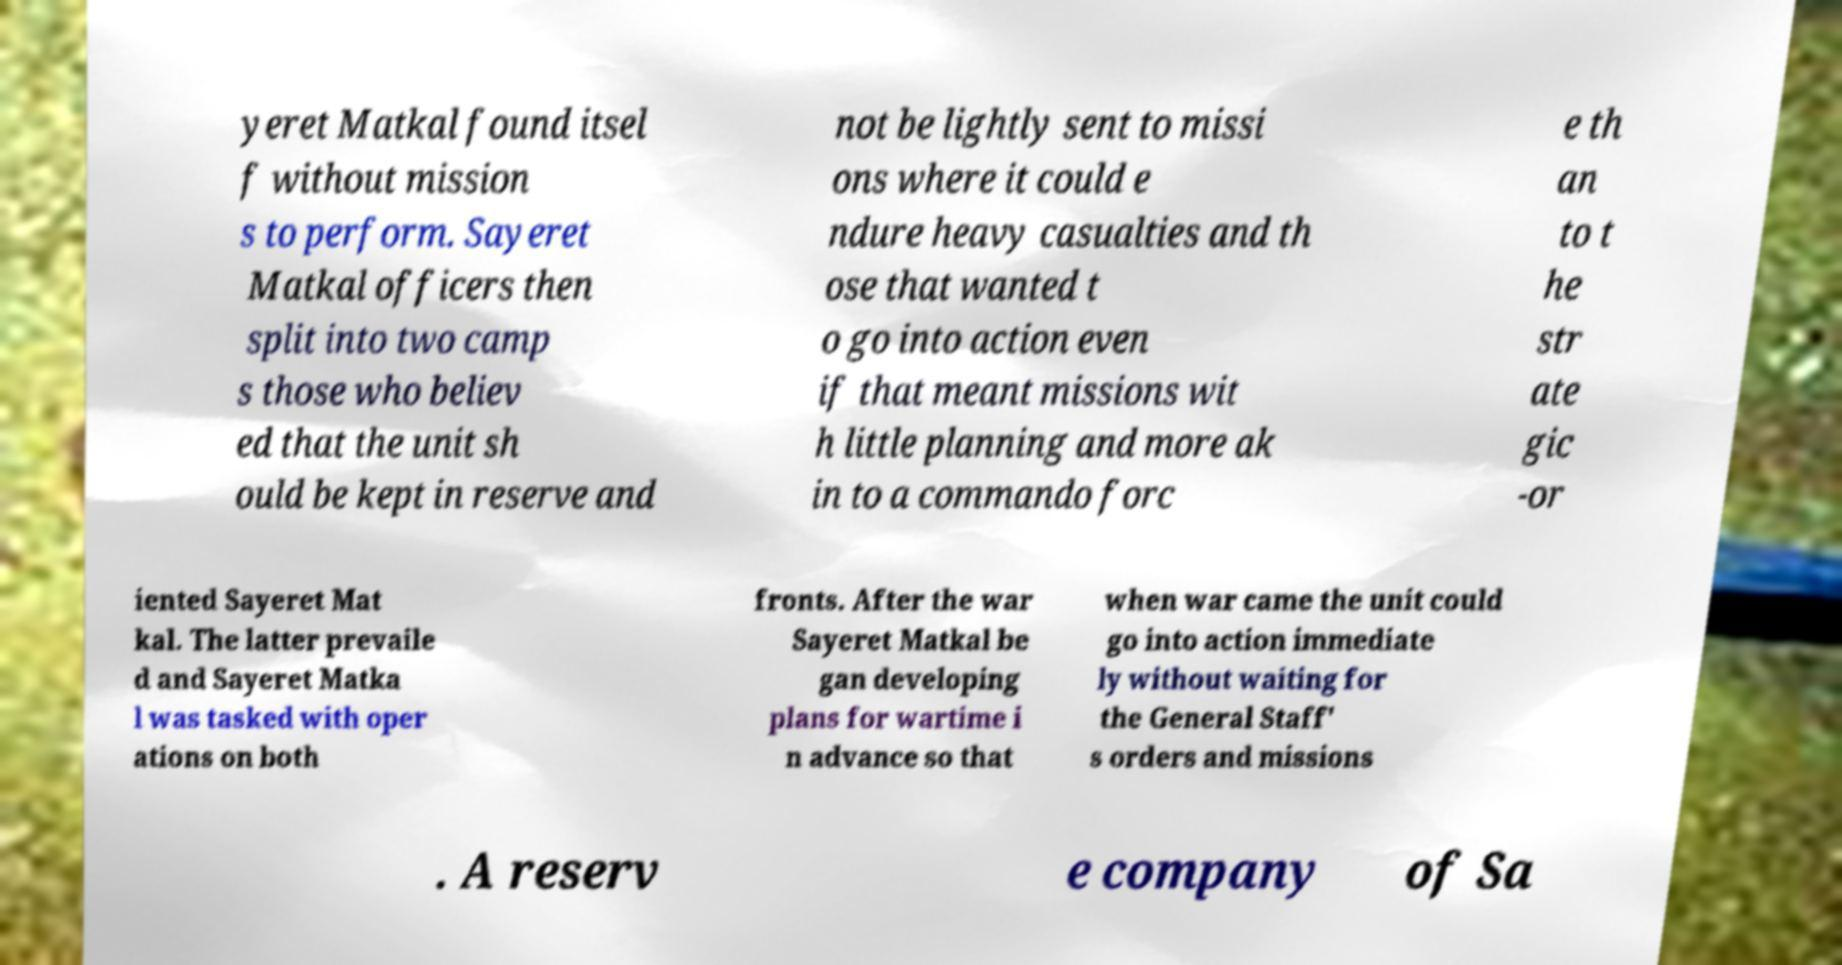For documentation purposes, I need the text within this image transcribed. Could you provide that? yeret Matkal found itsel f without mission s to perform. Sayeret Matkal officers then split into two camp s those who believ ed that the unit sh ould be kept in reserve and not be lightly sent to missi ons where it could e ndure heavy casualties and th ose that wanted t o go into action even if that meant missions wit h little planning and more ak in to a commando forc e th an to t he str ate gic -or iented Sayeret Mat kal. The latter prevaile d and Sayeret Matka l was tasked with oper ations on both fronts. After the war Sayeret Matkal be gan developing plans for wartime i n advance so that when war came the unit could go into action immediate ly without waiting for the General Staff' s orders and missions . A reserv e company of Sa 